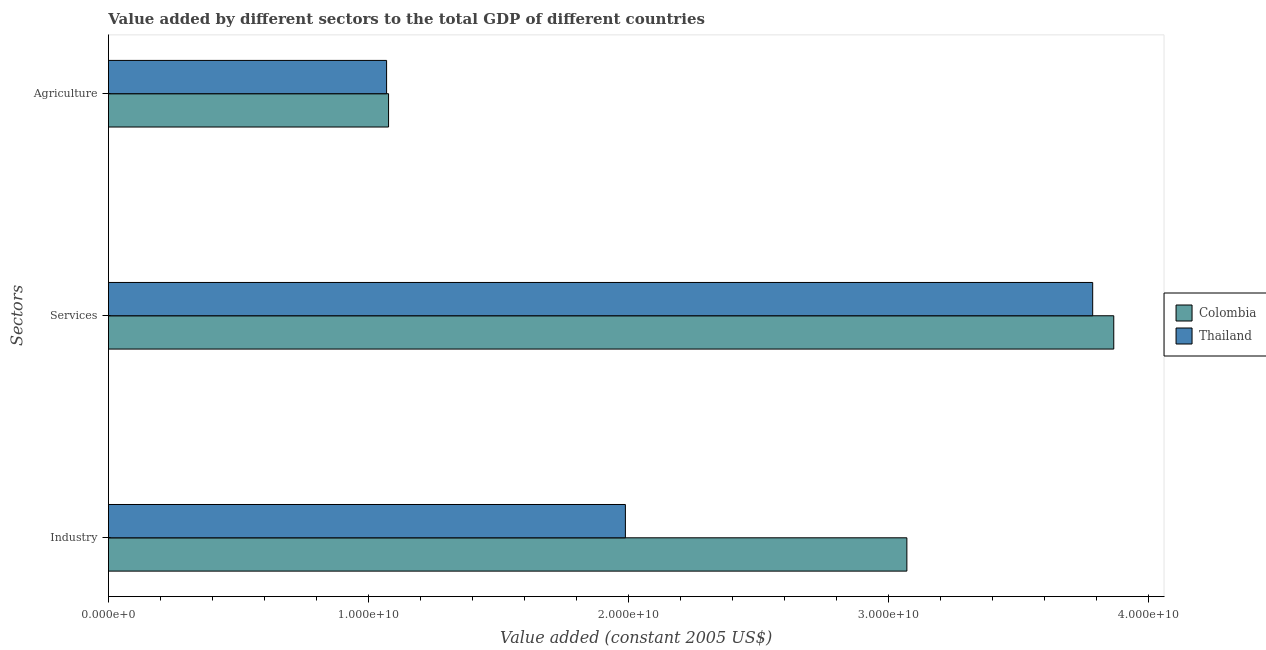How many different coloured bars are there?
Your response must be concise. 2. How many groups of bars are there?
Your answer should be very brief. 3. Are the number of bars per tick equal to the number of legend labels?
Make the answer very short. Yes. What is the label of the 1st group of bars from the top?
Make the answer very short. Agriculture. What is the value added by services in Colombia?
Provide a succinct answer. 3.87e+1. Across all countries, what is the maximum value added by industrial sector?
Your answer should be very brief. 3.07e+1. Across all countries, what is the minimum value added by services?
Ensure brevity in your answer.  3.78e+1. In which country was the value added by industrial sector maximum?
Your answer should be compact. Colombia. In which country was the value added by industrial sector minimum?
Your response must be concise. Thailand. What is the total value added by services in the graph?
Keep it short and to the point. 7.65e+1. What is the difference between the value added by agricultural sector in Colombia and that in Thailand?
Give a very brief answer. 7.56e+07. What is the difference between the value added by agricultural sector in Colombia and the value added by services in Thailand?
Offer a very short reply. -2.71e+1. What is the average value added by services per country?
Make the answer very short. 3.83e+1. What is the difference between the value added by agricultural sector and value added by industrial sector in Thailand?
Make the answer very short. -9.18e+09. What is the ratio of the value added by agricultural sector in Colombia to that in Thailand?
Ensure brevity in your answer.  1.01. What is the difference between the highest and the second highest value added by agricultural sector?
Your answer should be very brief. 7.56e+07. What is the difference between the highest and the lowest value added by agricultural sector?
Give a very brief answer. 7.56e+07. Is the sum of the value added by services in Colombia and Thailand greater than the maximum value added by agricultural sector across all countries?
Offer a very short reply. Yes. What does the 1st bar from the top in Agriculture represents?
Ensure brevity in your answer.  Thailand. What does the 1st bar from the bottom in Services represents?
Give a very brief answer. Colombia. How many bars are there?
Ensure brevity in your answer.  6. What is the difference between two consecutive major ticks on the X-axis?
Give a very brief answer. 1.00e+1. Are the values on the major ticks of X-axis written in scientific E-notation?
Keep it short and to the point. Yes. Does the graph contain any zero values?
Keep it short and to the point. No. Where does the legend appear in the graph?
Your response must be concise. Center right. How many legend labels are there?
Ensure brevity in your answer.  2. How are the legend labels stacked?
Make the answer very short. Vertical. What is the title of the graph?
Make the answer very short. Value added by different sectors to the total GDP of different countries. What is the label or title of the X-axis?
Your response must be concise. Value added (constant 2005 US$). What is the label or title of the Y-axis?
Offer a terse response. Sectors. What is the Value added (constant 2005 US$) in Colombia in Industry?
Provide a short and direct response. 3.07e+1. What is the Value added (constant 2005 US$) of Thailand in Industry?
Offer a very short reply. 1.99e+1. What is the Value added (constant 2005 US$) in Colombia in Services?
Provide a succinct answer. 3.87e+1. What is the Value added (constant 2005 US$) of Thailand in Services?
Your response must be concise. 3.78e+1. What is the Value added (constant 2005 US$) of Colombia in Agriculture?
Your response must be concise. 1.08e+1. What is the Value added (constant 2005 US$) in Thailand in Agriculture?
Offer a terse response. 1.07e+1. Across all Sectors, what is the maximum Value added (constant 2005 US$) in Colombia?
Provide a short and direct response. 3.87e+1. Across all Sectors, what is the maximum Value added (constant 2005 US$) in Thailand?
Give a very brief answer. 3.78e+1. Across all Sectors, what is the minimum Value added (constant 2005 US$) of Colombia?
Your response must be concise. 1.08e+1. Across all Sectors, what is the minimum Value added (constant 2005 US$) in Thailand?
Your answer should be compact. 1.07e+1. What is the total Value added (constant 2005 US$) in Colombia in the graph?
Offer a very short reply. 8.01e+1. What is the total Value added (constant 2005 US$) in Thailand in the graph?
Ensure brevity in your answer.  6.84e+1. What is the difference between the Value added (constant 2005 US$) in Colombia in Industry and that in Services?
Offer a terse response. -7.96e+09. What is the difference between the Value added (constant 2005 US$) in Thailand in Industry and that in Services?
Ensure brevity in your answer.  -1.80e+1. What is the difference between the Value added (constant 2005 US$) in Colombia in Industry and that in Agriculture?
Keep it short and to the point. 1.99e+1. What is the difference between the Value added (constant 2005 US$) in Thailand in Industry and that in Agriculture?
Offer a terse response. 9.18e+09. What is the difference between the Value added (constant 2005 US$) of Colombia in Services and that in Agriculture?
Your response must be concise. 2.79e+1. What is the difference between the Value added (constant 2005 US$) of Thailand in Services and that in Agriculture?
Make the answer very short. 2.71e+1. What is the difference between the Value added (constant 2005 US$) in Colombia in Industry and the Value added (constant 2005 US$) in Thailand in Services?
Make the answer very short. -7.14e+09. What is the difference between the Value added (constant 2005 US$) in Colombia in Industry and the Value added (constant 2005 US$) in Thailand in Agriculture?
Provide a short and direct response. 2.00e+1. What is the difference between the Value added (constant 2005 US$) of Colombia in Services and the Value added (constant 2005 US$) of Thailand in Agriculture?
Your answer should be compact. 2.80e+1. What is the average Value added (constant 2005 US$) of Colombia per Sectors?
Your response must be concise. 2.67e+1. What is the average Value added (constant 2005 US$) in Thailand per Sectors?
Give a very brief answer. 2.28e+1. What is the difference between the Value added (constant 2005 US$) of Colombia and Value added (constant 2005 US$) of Thailand in Industry?
Offer a very short reply. 1.08e+1. What is the difference between the Value added (constant 2005 US$) in Colombia and Value added (constant 2005 US$) in Thailand in Services?
Ensure brevity in your answer.  8.11e+08. What is the difference between the Value added (constant 2005 US$) of Colombia and Value added (constant 2005 US$) of Thailand in Agriculture?
Keep it short and to the point. 7.56e+07. What is the ratio of the Value added (constant 2005 US$) of Colombia in Industry to that in Services?
Offer a very short reply. 0.79. What is the ratio of the Value added (constant 2005 US$) of Thailand in Industry to that in Services?
Provide a short and direct response. 0.53. What is the ratio of the Value added (constant 2005 US$) in Colombia in Industry to that in Agriculture?
Your response must be concise. 2.85. What is the ratio of the Value added (constant 2005 US$) in Thailand in Industry to that in Agriculture?
Your response must be concise. 1.86. What is the ratio of the Value added (constant 2005 US$) in Colombia in Services to that in Agriculture?
Give a very brief answer. 3.59. What is the ratio of the Value added (constant 2005 US$) in Thailand in Services to that in Agriculture?
Ensure brevity in your answer.  3.54. What is the difference between the highest and the second highest Value added (constant 2005 US$) of Colombia?
Ensure brevity in your answer.  7.96e+09. What is the difference between the highest and the second highest Value added (constant 2005 US$) of Thailand?
Your answer should be compact. 1.80e+1. What is the difference between the highest and the lowest Value added (constant 2005 US$) in Colombia?
Keep it short and to the point. 2.79e+1. What is the difference between the highest and the lowest Value added (constant 2005 US$) in Thailand?
Your answer should be compact. 2.71e+1. 